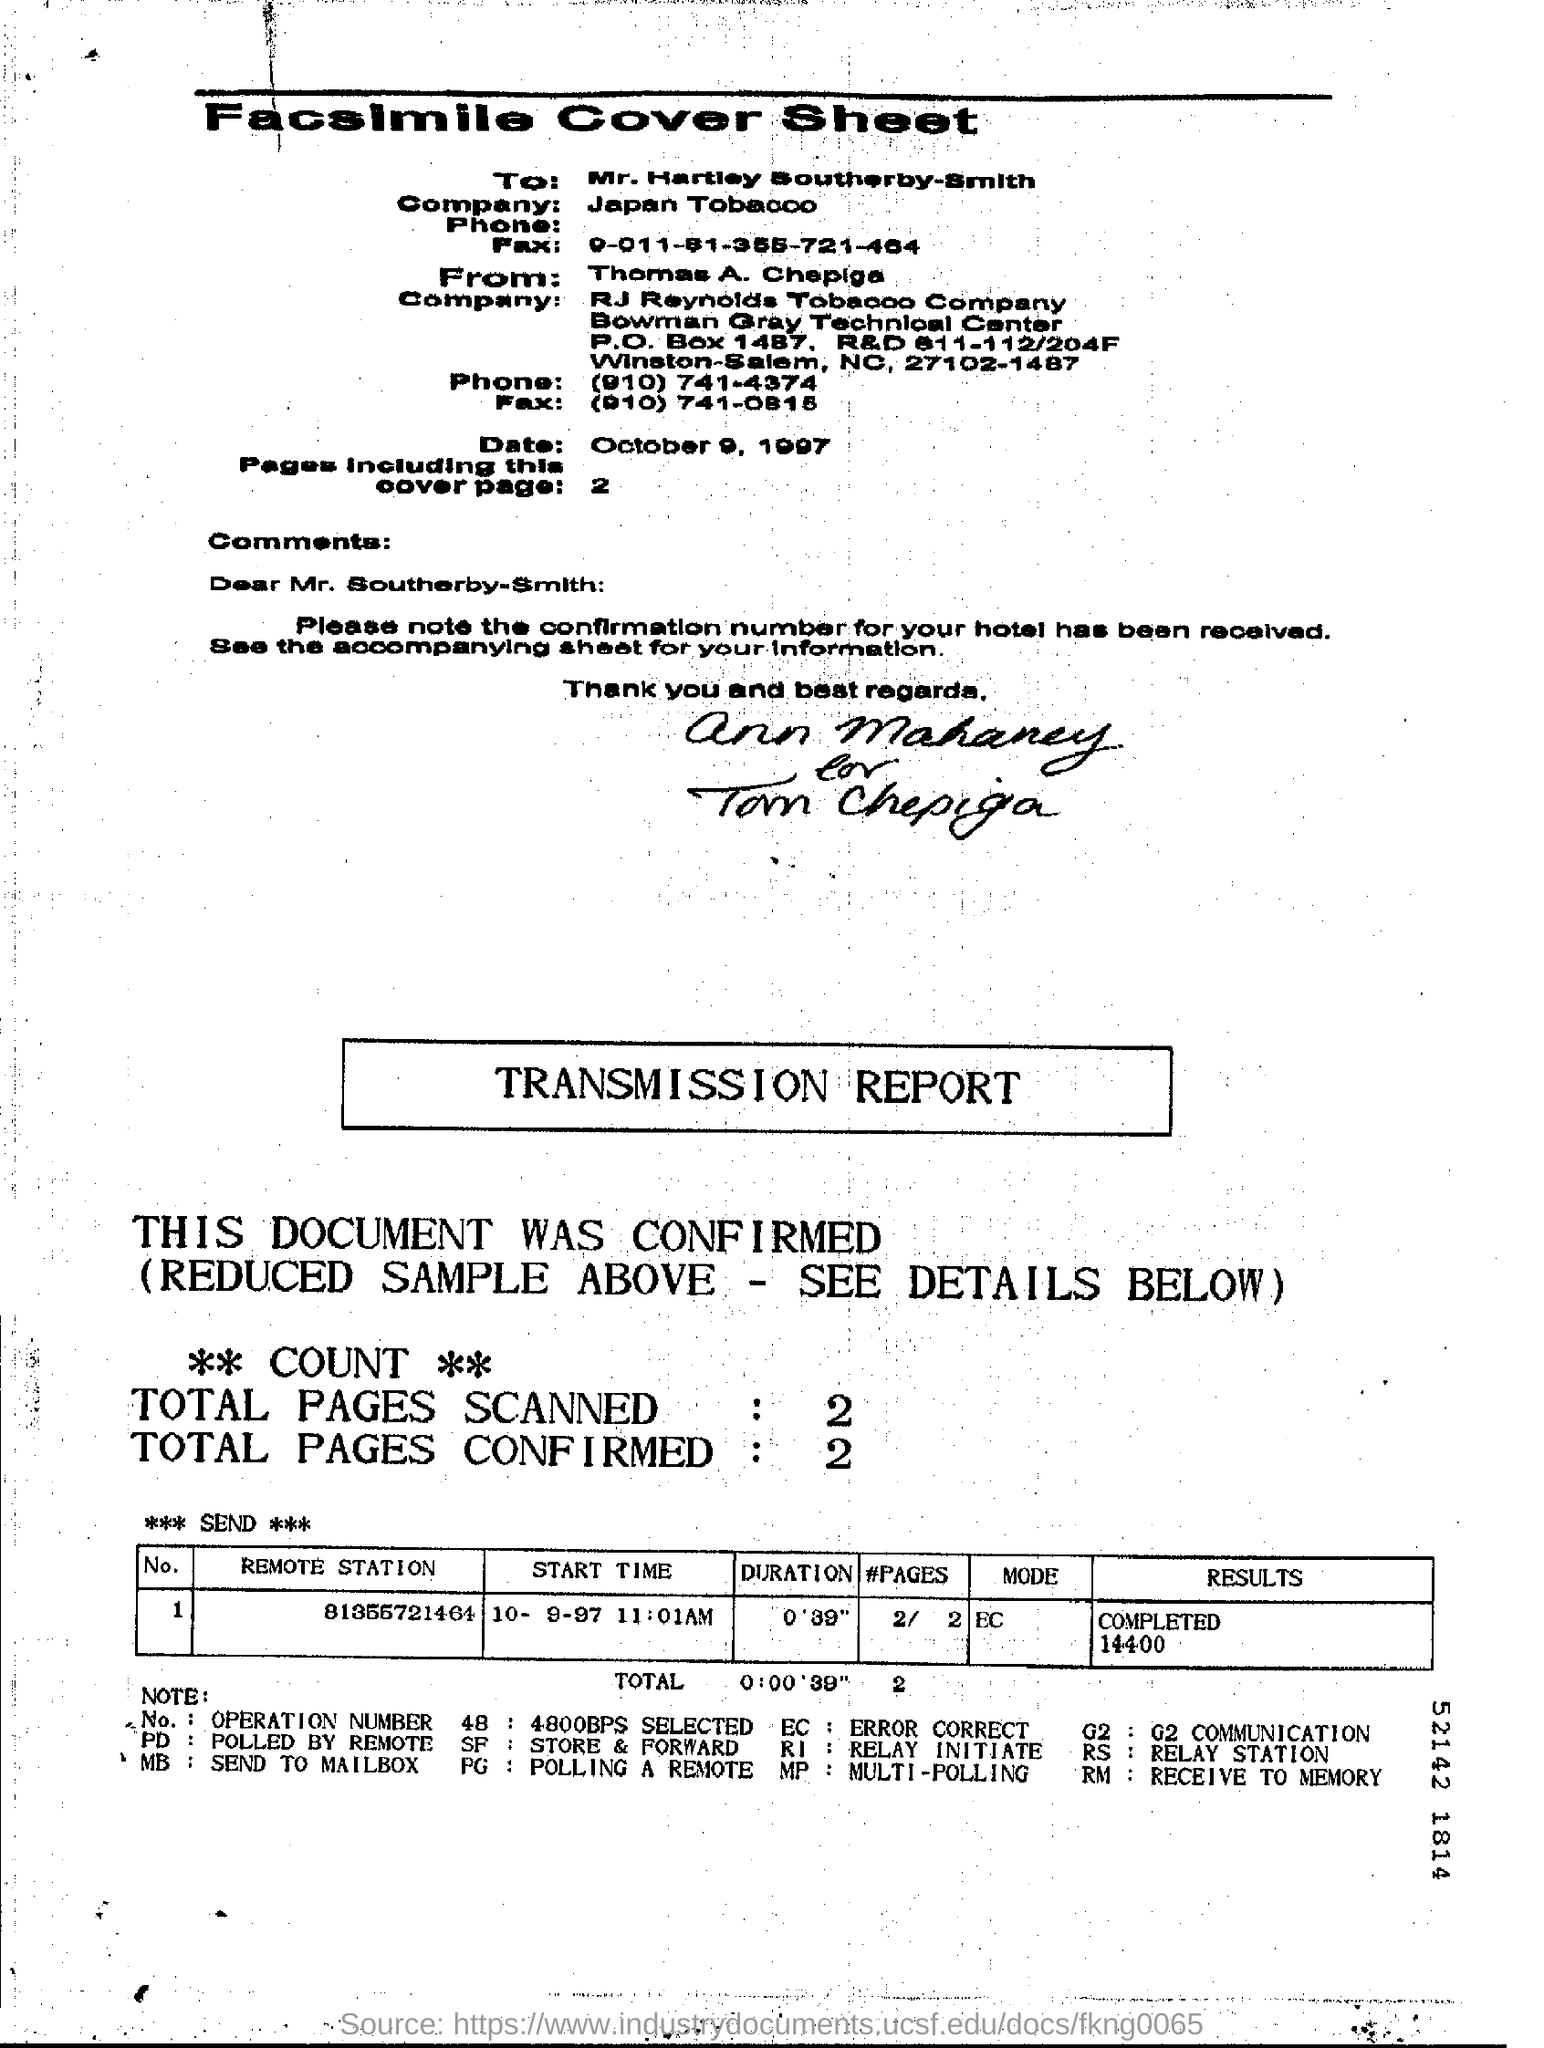How many pages are there in the fax including cover page?
Make the answer very short. 2. What is the Start time mentioned in the transmission report?
Provide a succinct answer. 10 -9-97  11:01AM. Which Remote station belongs to Operation Number(No.) 1?
Your response must be concise. 81355721464. 